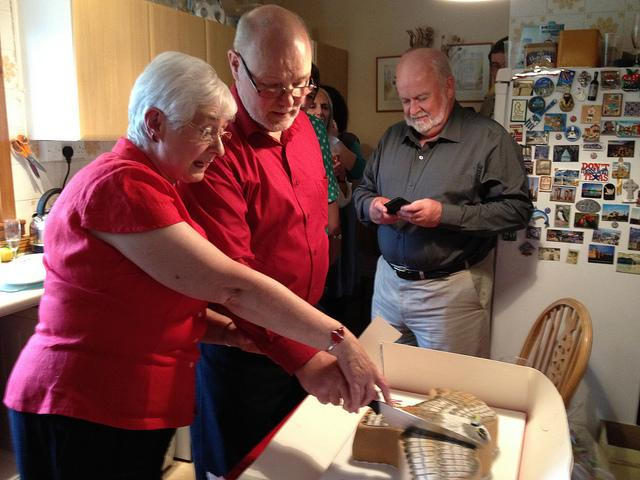What type of building are they in? house 